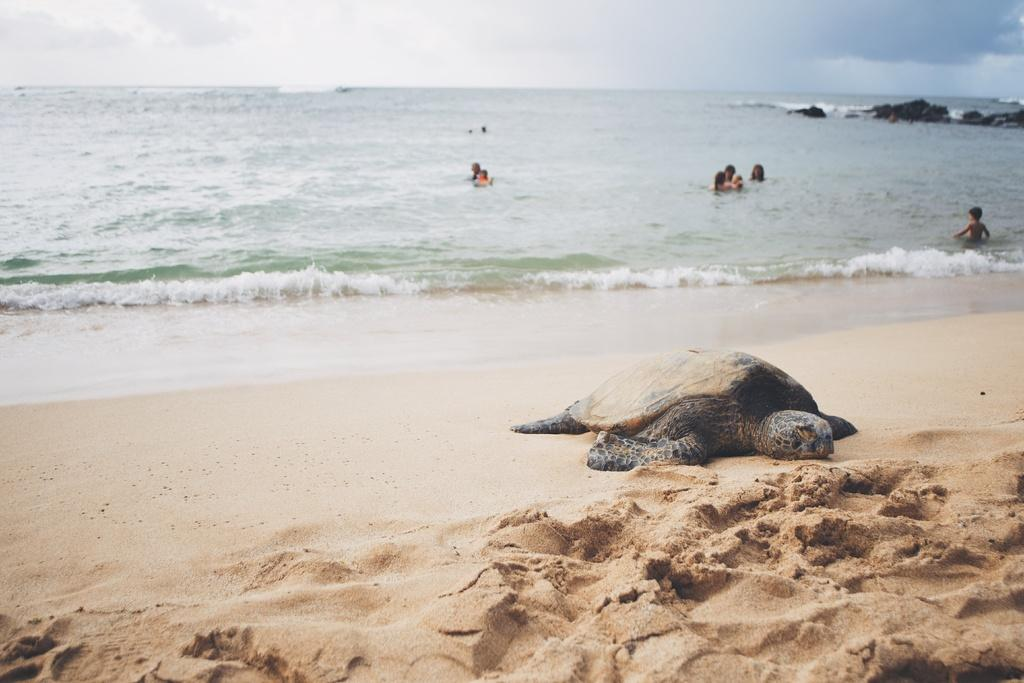What animal can be seen on the beach in the image? There is a tortoise on a beach in the image. What activity can be seen in the background of the image? There are people swimming in the sea in the background of the image. What part of the natural environment is visible in the image? The sky is visible in the image. What type of oil can be seen dripping from the tortoise in the image? There is no oil present in the image, and the tortoise is not depicted as dripping anything. 